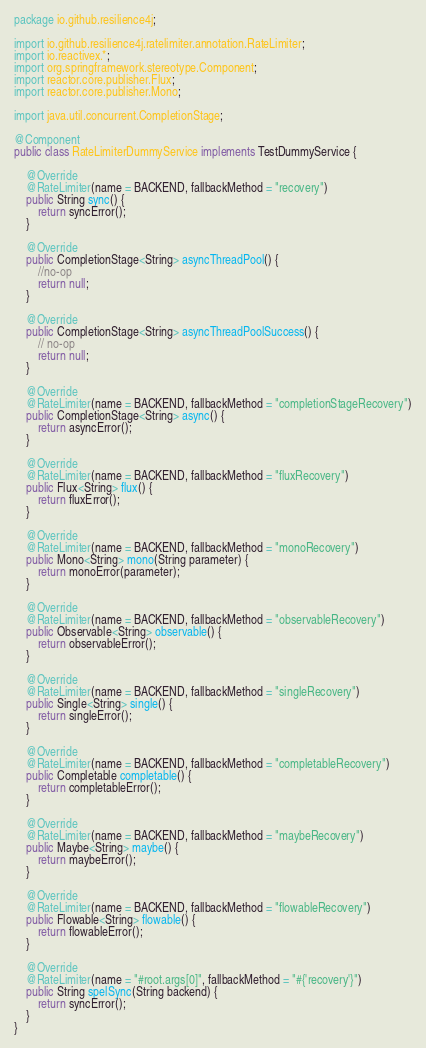Convert code to text. <code><loc_0><loc_0><loc_500><loc_500><_Java_>package io.github.resilience4j;

import io.github.resilience4j.ratelimiter.annotation.RateLimiter;
import io.reactivex.*;
import org.springframework.stereotype.Component;
import reactor.core.publisher.Flux;
import reactor.core.publisher.Mono;

import java.util.concurrent.CompletionStage;

@Component
public class RateLimiterDummyService implements TestDummyService {

    @Override
    @RateLimiter(name = BACKEND, fallbackMethod = "recovery")
    public String sync() {
        return syncError();
    }

    @Override
    public CompletionStage<String> asyncThreadPool() {
        //no-op
        return null;
    }

    @Override
    public CompletionStage<String> asyncThreadPoolSuccess() {
        // no-op
        return null;
    }

    @Override
    @RateLimiter(name = BACKEND, fallbackMethod = "completionStageRecovery")
    public CompletionStage<String> async() {
        return asyncError();
    }

    @Override
    @RateLimiter(name = BACKEND, fallbackMethod = "fluxRecovery")
    public Flux<String> flux() {
        return fluxError();
    }

    @Override
    @RateLimiter(name = BACKEND, fallbackMethod = "monoRecovery")
    public Mono<String> mono(String parameter) {
        return monoError(parameter);
    }

    @Override
    @RateLimiter(name = BACKEND, fallbackMethod = "observableRecovery")
    public Observable<String> observable() {
        return observableError();
    }

    @Override
    @RateLimiter(name = BACKEND, fallbackMethod = "singleRecovery")
    public Single<String> single() {
        return singleError();
    }

    @Override
    @RateLimiter(name = BACKEND, fallbackMethod = "completableRecovery")
    public Completable completable() {
        return completableError();
    }

    @Override
    @RateLimiter(name = BACKEND, fallbackMethod = "maybeRecovery")
    public Maybe<String> maybe() {
        return maybeError();
    }

    @Override
    @RateLimiter(name = BACKEND, fallbackMethod = "flowableRecovery")
    public Flowable<String> flowable() {
        return flowableError();
    }

    @Override
    @RateLimiter(name = "#root.args[0]", fallbackMethod = "#{'recovery'}")
    public String spelSync(String backend) {
        return syncError();
    }
}
</code> 